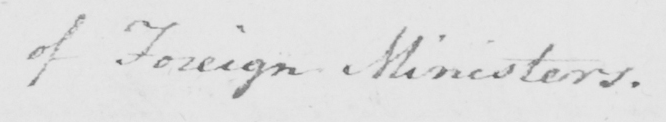What is written in this line of handwriting? of Foreign Ministers . 